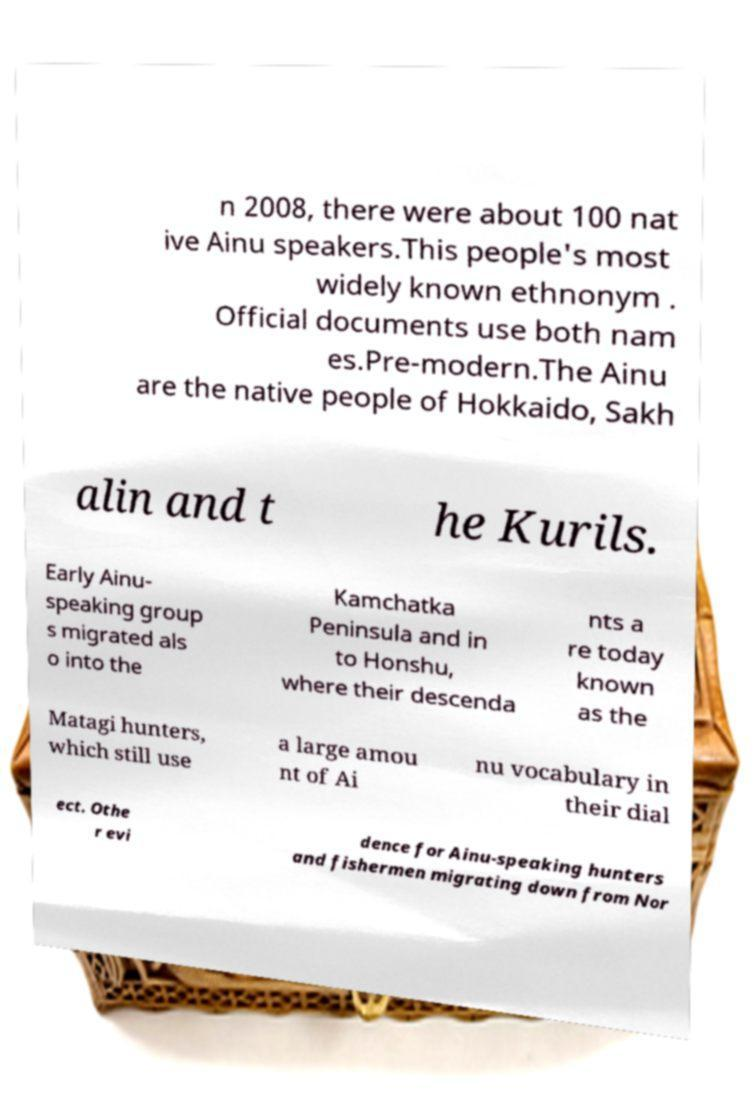Please read and relay the text visible in this image. What does it say? n 2008, there were about 100 nat ive Ainu speakers.This people's most widely known ethnonym . Official documents use both nam es.Pre-modern.The Ainu are the native people of Hokkaido, Sakh alin and t he Kurils. Early Ainu- speaking group s migrated als o into the Kamchatka Peninsula and in to Honshu, where their descenda nts a re today known as the Matagi hunters, which still use a large amou nt of Ai nu vocabulary in their dial ect. Othe r evi dence for Ainu-speaking hunters and fishermen migrating down from Nor 